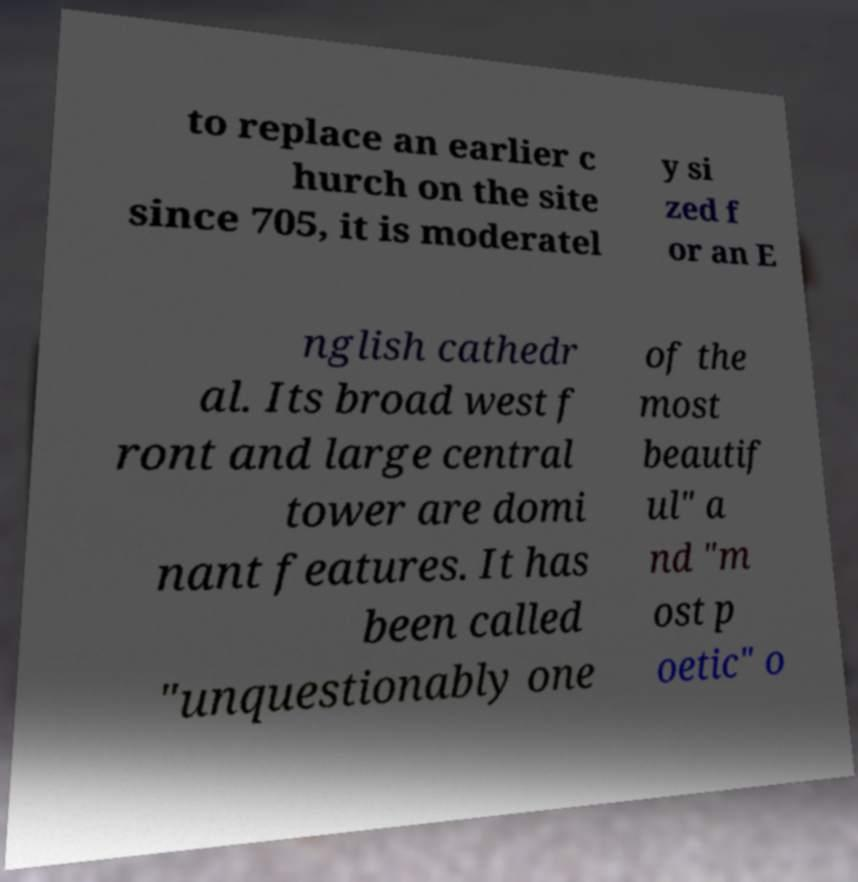Could you extract and type out the text from this image? to replace an earlier c hurch on the site since 705, it is moderatel y si zed f or an E nglish cathedr al. Its broad west f ront and large central tower are domi nant features. It has been called "unquestionably one of the most beautif ul" a nd "m ost p oetic" o 